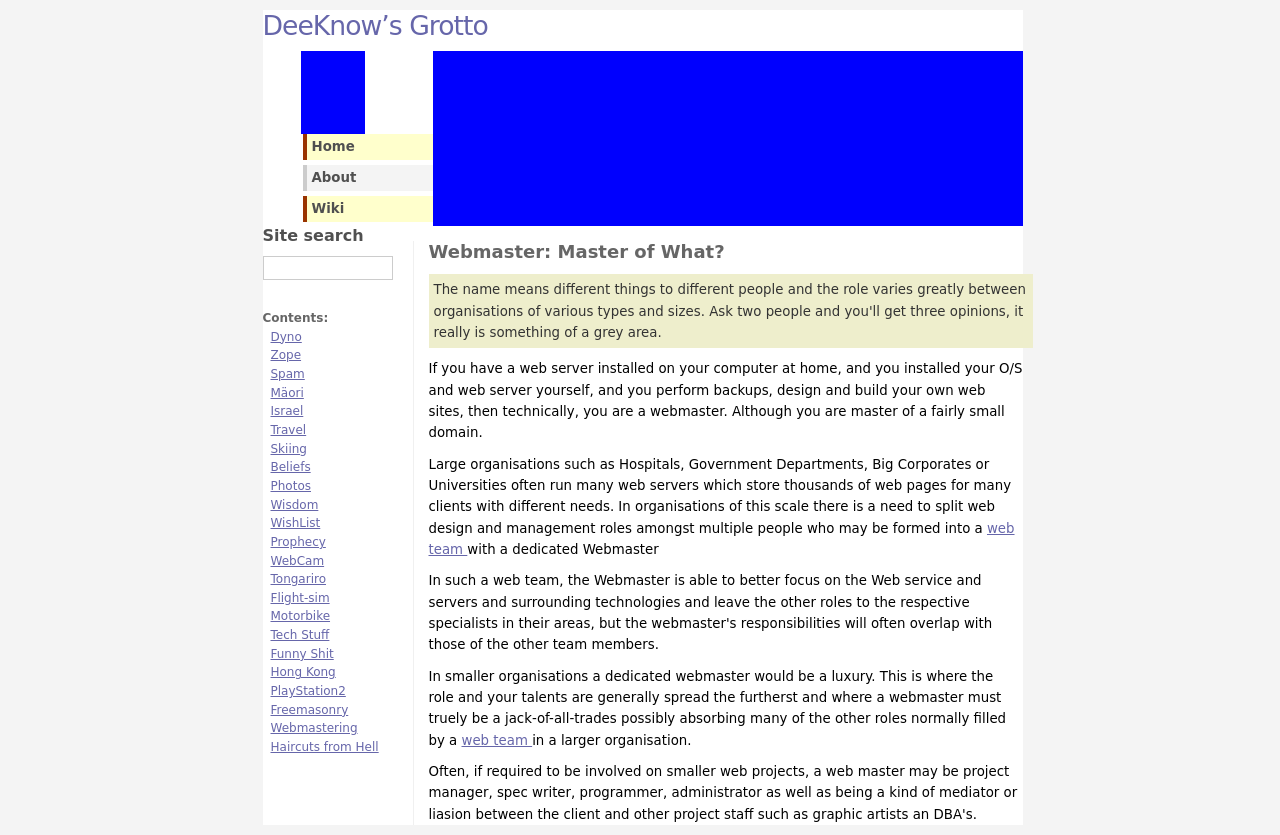Can you explain the importance of having a 'Webmaster' title in digital projects as discussed in the text? The title 'Webmaster' in digital projects denotes responsibility for maintaining and managing a website's infrastructure. This role is crucial as it ensures the technical health of the site, handles server management, website architecture, and adherence to tech standards. Depending on the organization's size, a Webmaster may also liaise with content creators, manage SEO, and oversee the site's security aspects. 